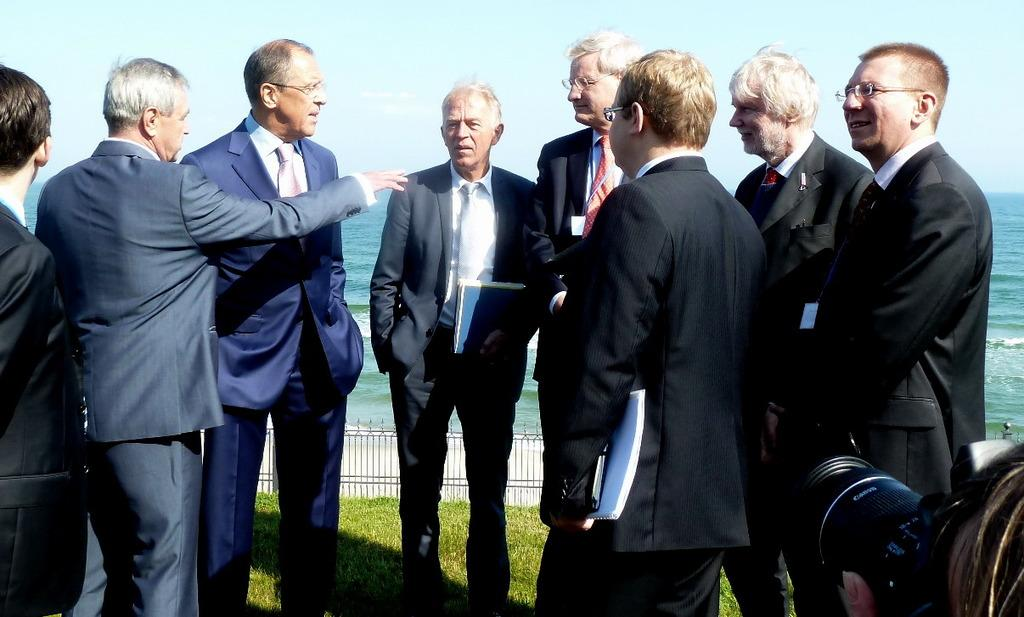What are the people in the image doing? There are many people standing and talking in the image. What else are some people doing in the image? Some people are catching books in the image. What type of barrier can be seen in the image? There is an iron pole fence in the image. What natural element is visible in the image? Water is visible in the image. How is the sky depicted in the image? The sky is clear in the image. How many fifths are present in the image? There is no reference to a "fifth" in the image, so it is not possible to answer that question. --- Facts: 1. There is a person sitting on a chair in the image. 2. The person is holding a book. 3. There is a table next to the chair. 4. The table has a lamp on it. 5. The background of the image is a room. Absurd Topics: elephant, ocean, bicycle Conversation: What is the person in the image doing? The person is sitting on a chair in the image and holding a book. What object is next to the chair? There is a table next to the chair. What is on the table? The table has a lamp on it. What type of setting is depicted in the image? The background of the image is a room. Reasoning: Let's think step by step in order to produce the conversation. We start by describing the main subject in the image, which is the person sitting on a chair and holding a book. Then, we mention the object next to the chair, which is a table. We describe what is on the table, which is a lamp. Finally, we identify the type of setting depicted in the image, which is a room. Absurd Question/Answer: Can you see an elephant swimming in the ocean in the image? There is no elephant or ocean present in the image; it depicts a person sitting in a room with a book, table, and lamp. 